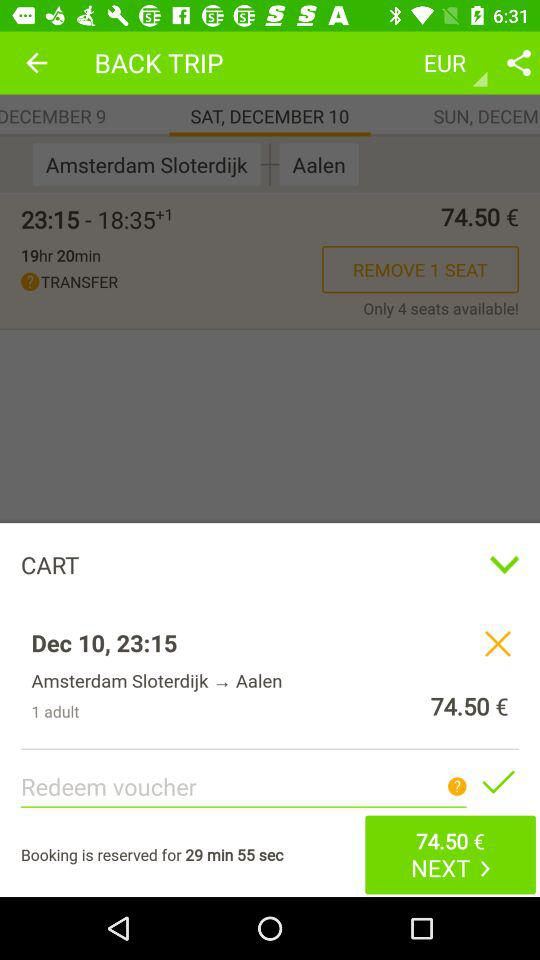How much is the ticket price for the same trip tomorrow?
When the provided information is insufficient, respond with <no answer>. <no answer> 